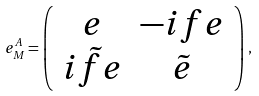<formula> <loc_0><loc_0><loc_500><loc_500>e ^ { A } _ { M } = \left ( \begin{array} { c c } e & - i f e \\ i \tilde { f } e & \tilde { e } \end{array} \right ) \, ,</formula> 